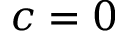<formula> <loc_0><loc_0><loc_500><loc_500>c = 0</formula> 